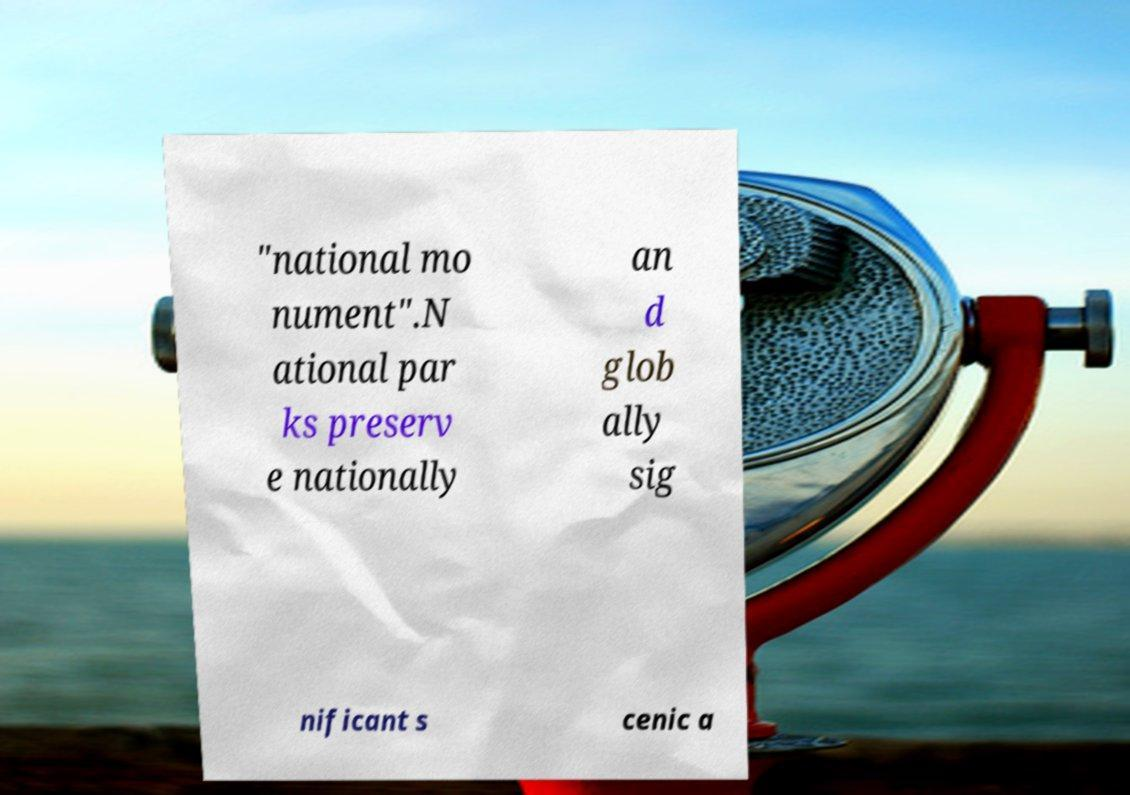For documentation purposes, I need the text within this image transcribed. Could you provide that? "national mo nument".N ational par ks preserv e nationally an d glob ally sig nificant s cenic a 